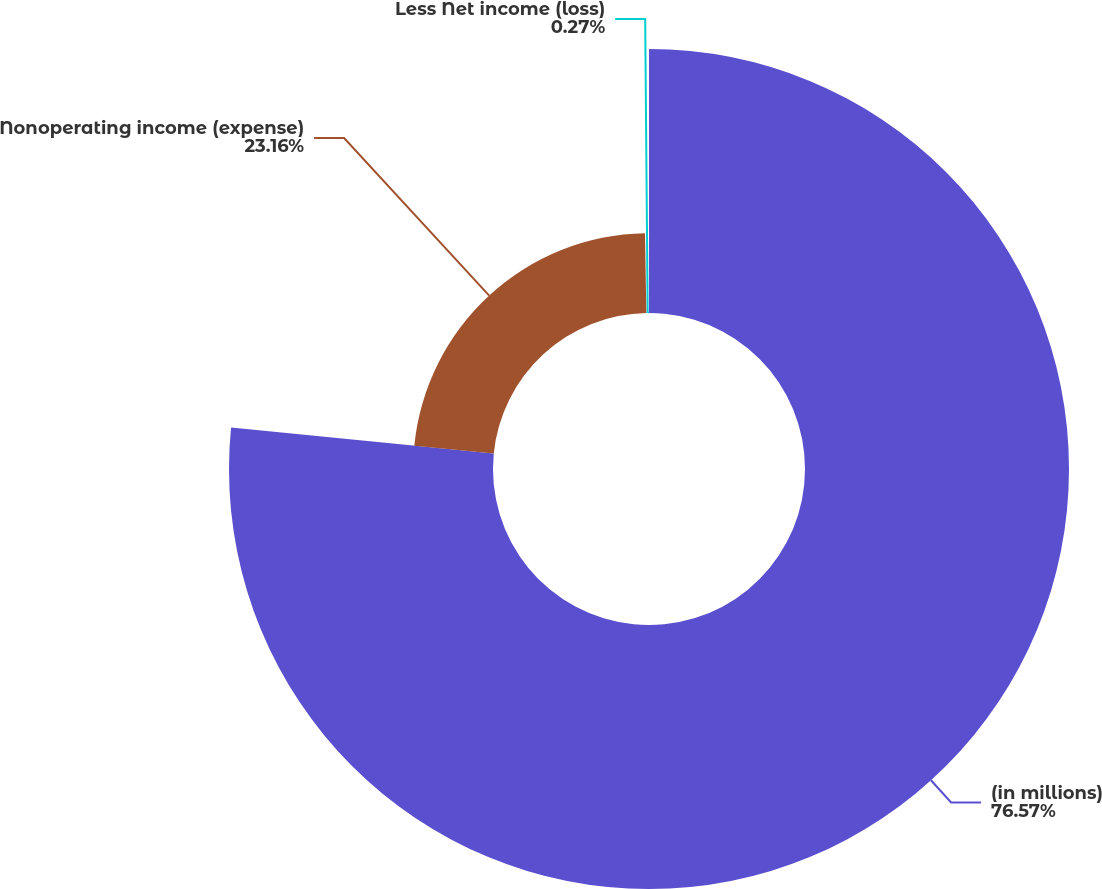Convert chart to OTSL. <chart><loc_0><loc_0><loc_500><loc_500><pie_chart><fcel>(in millions)<fcel>Nonoperating income (expense)<fcel>Less Net income (loss)<nl><fcel>76.58%<fcel>23.16%<fcel>0.27%<nl></chart> 